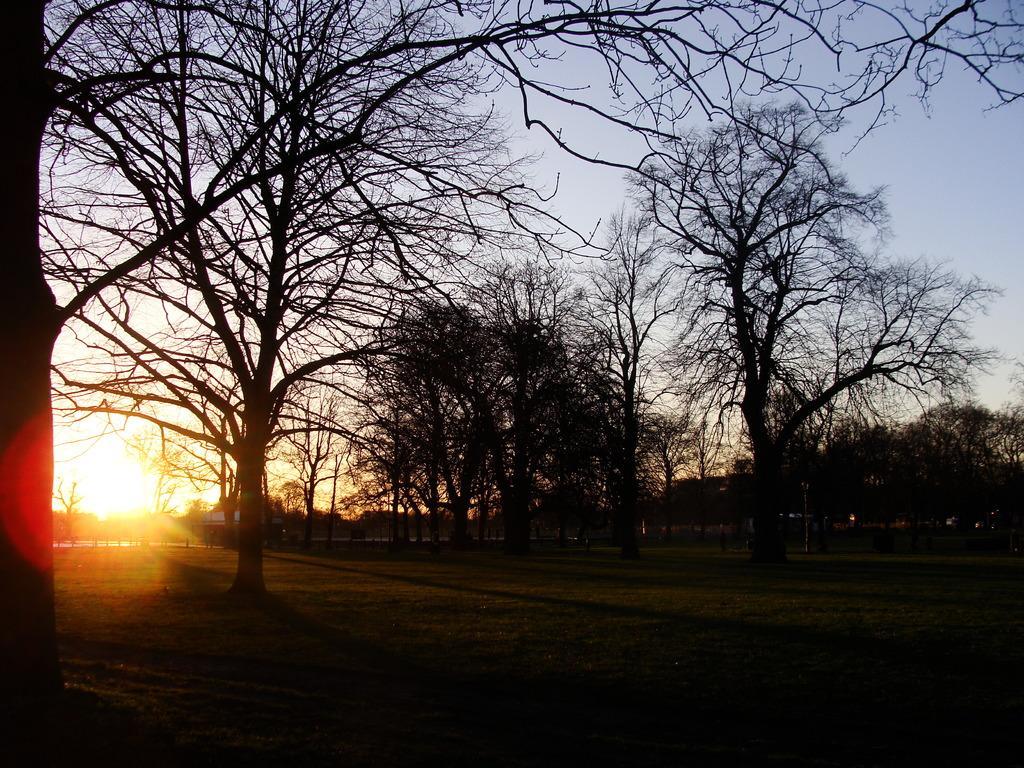Can you describe this image briefly? In this image we can see trees, sunlight and sky.   